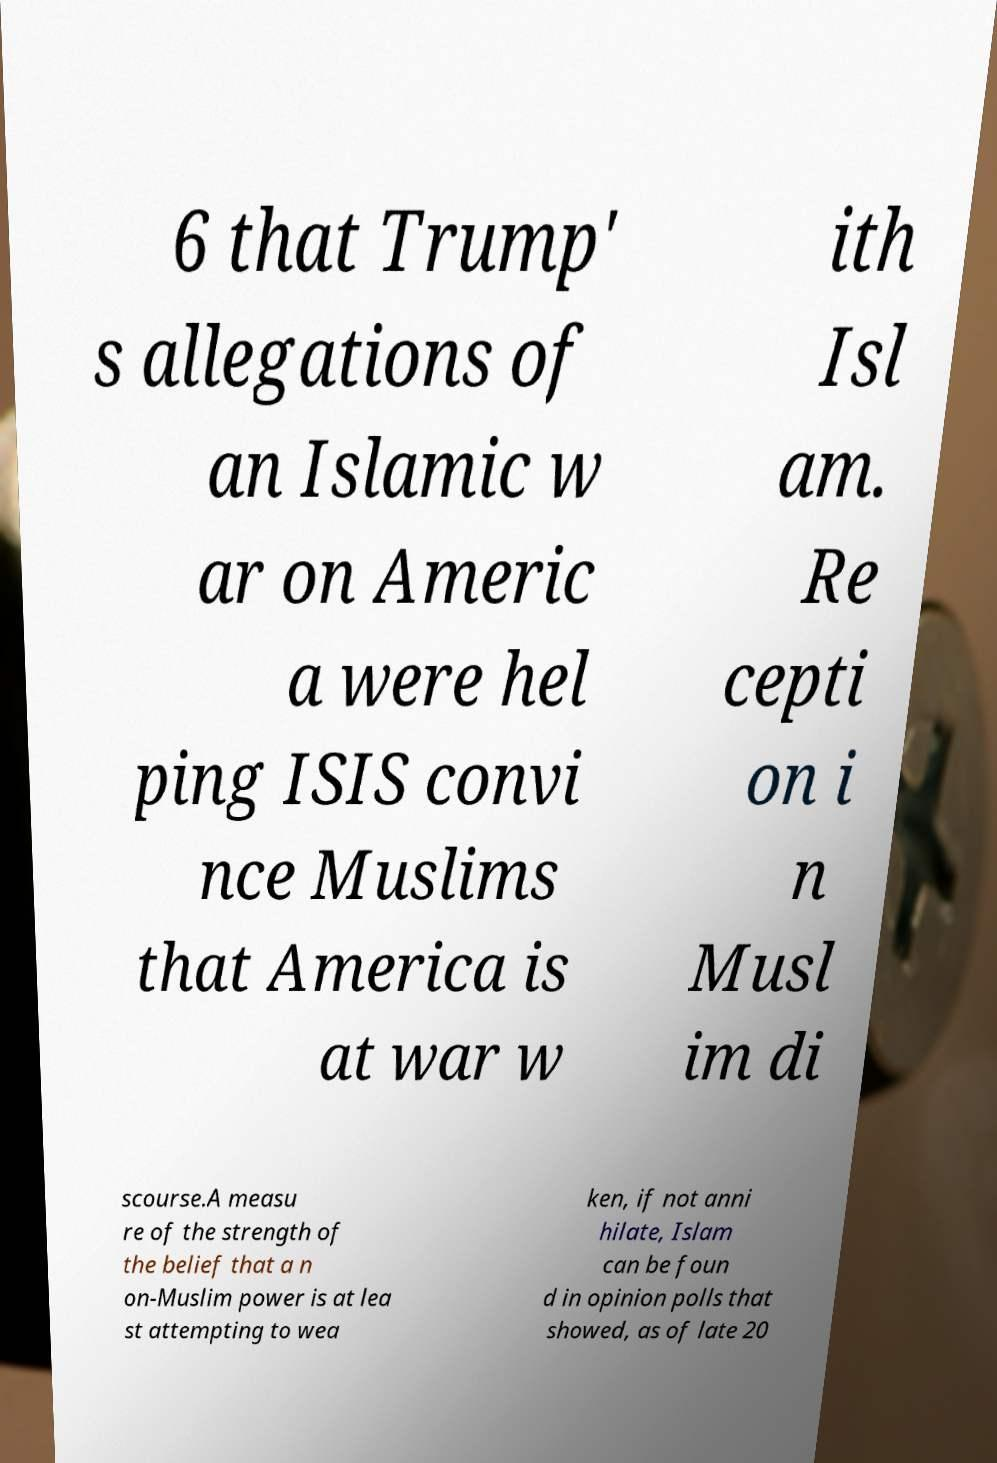Could you extract and type out the text from this image? 6 that Trump' s allegations of an Islamic w ar on Americ a were hel ping ISIS convi nce Muslims that America is at war w ith Isl am. Re cepti on i n Musl im di scourse.A measu re of the strength of the belief that a n on-Muslim power is at lea st attempting to wea ken, if not anni hilate, Islam can be foun d in opinion polls that showed, as of late 20 